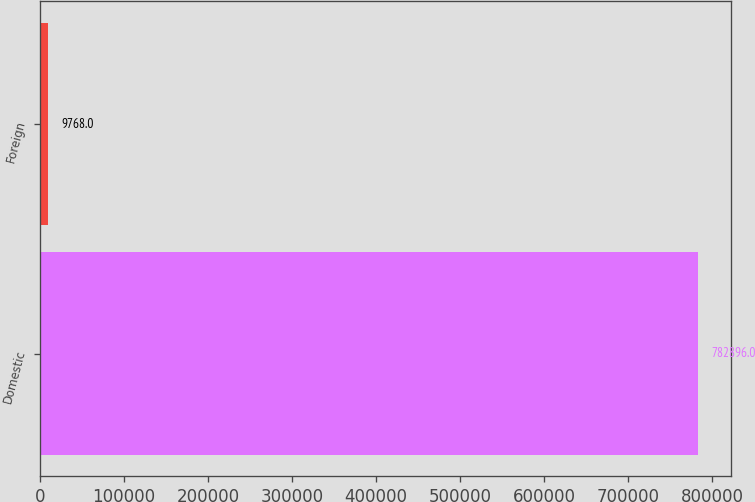<chart> <loc_0><loc_0><loc_500><loc_500><bar_chart><fcel>Domestic<fcel>Foreign<nl><fcel>782896<fcel>9768<nl></chart> 